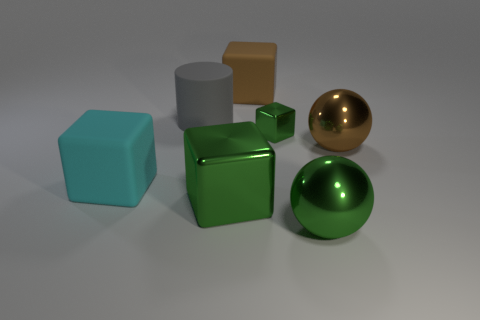Subtract all tiny shiny cubes. How many cubes are left? 3 Subtract 1 cubes. How many cubes are left? 3 Add 3 red shiny spheres. How many objects exist? 10 Subtract all gray blocks. Subtract all cyan spheres. How many blocks are left? 4 Subtract all cubes. How many objects are left? 3 Add 6 small cyan rubber cubes. How many small cyan rubber cubes exist? 6 Subtract 0 red cylinders. How many objects are left? 7 Subtract all large matte cylinders. Subtract all small gray metallic blocks. How many objects are left? 6 Add 3 brown metal objects. How many brown metal objects are left? 4 